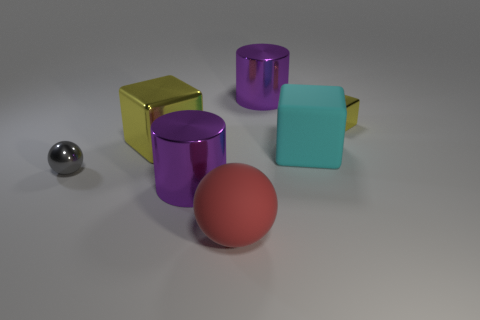Is the number of red matte things that are left of the large shiny block greater than the number of blue shiny blocks? In analyzing the image, it's visible that there is only one red matte sphere, and it is indeed located to the left of the large shiny yellow cube. Upon reviewing the other objects, there are no blue shiny blocks present at all. Therefore, the answer is yes, the number of red matte things to the left of the large shiny block, which is one, is greater than the number of blue shiny blocks, since there are none. 